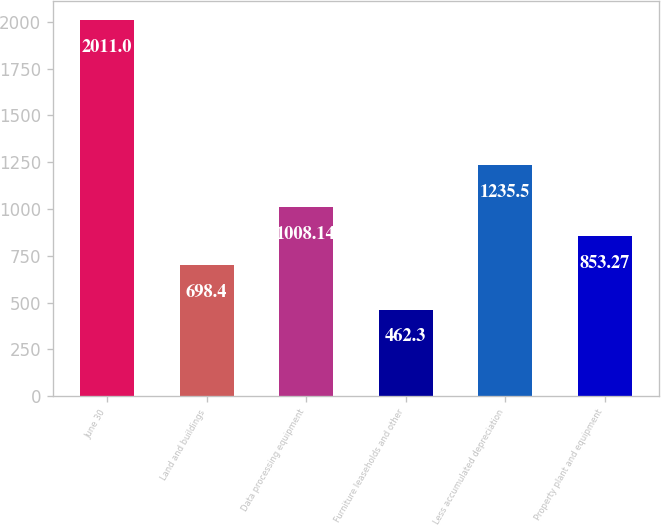<chart> <loc_0><loc_0><loc_500><loc_500><bar_chart><fcel>June 30<fcel>Land and buildings<fcel>Data processing equipment<fcel>Furniture leaseholds and other<fcel>Less accumulated depreciation<fcel>Property plant and equipment<nl><fcel>2011<fcel>698.4<fcel>1008.14<fcel>462.3<fcel>1235.5<fcel>853.27<nl></chart> 